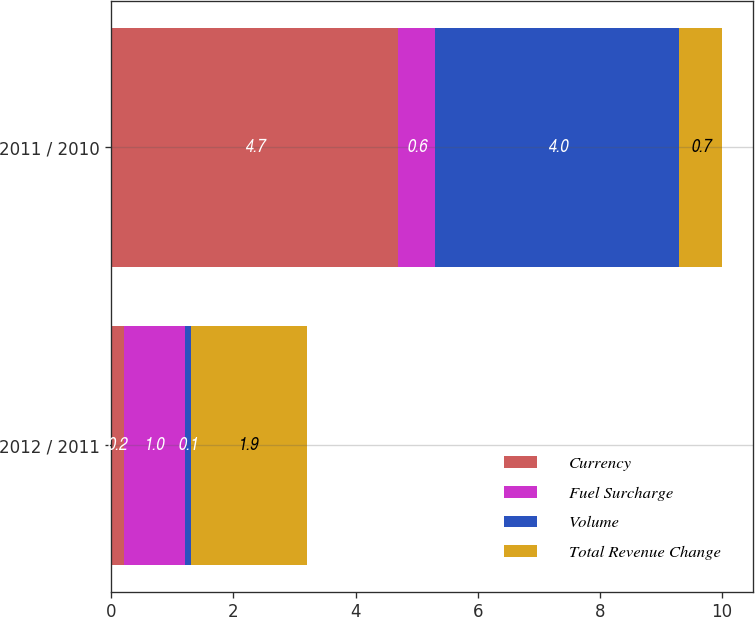Convert chart to OTSL. <chart><loc_0><loc_0><loc_500><loc_500><stacked_bar_chart><ecel><fcel>2012 / 2011<fcel>2011 / 2010<nl><fcel>Currency<fcel>0.2<fcel>4.7<nl><fcel>Fuel Surcharge<fcel>1<fcel>0.6<nl><fcel>Volume<fcel>0.1<fcel>4<nl><fcel>Total Revenue Change<fcel>1.9<fcel>0.7<nl></chart> 